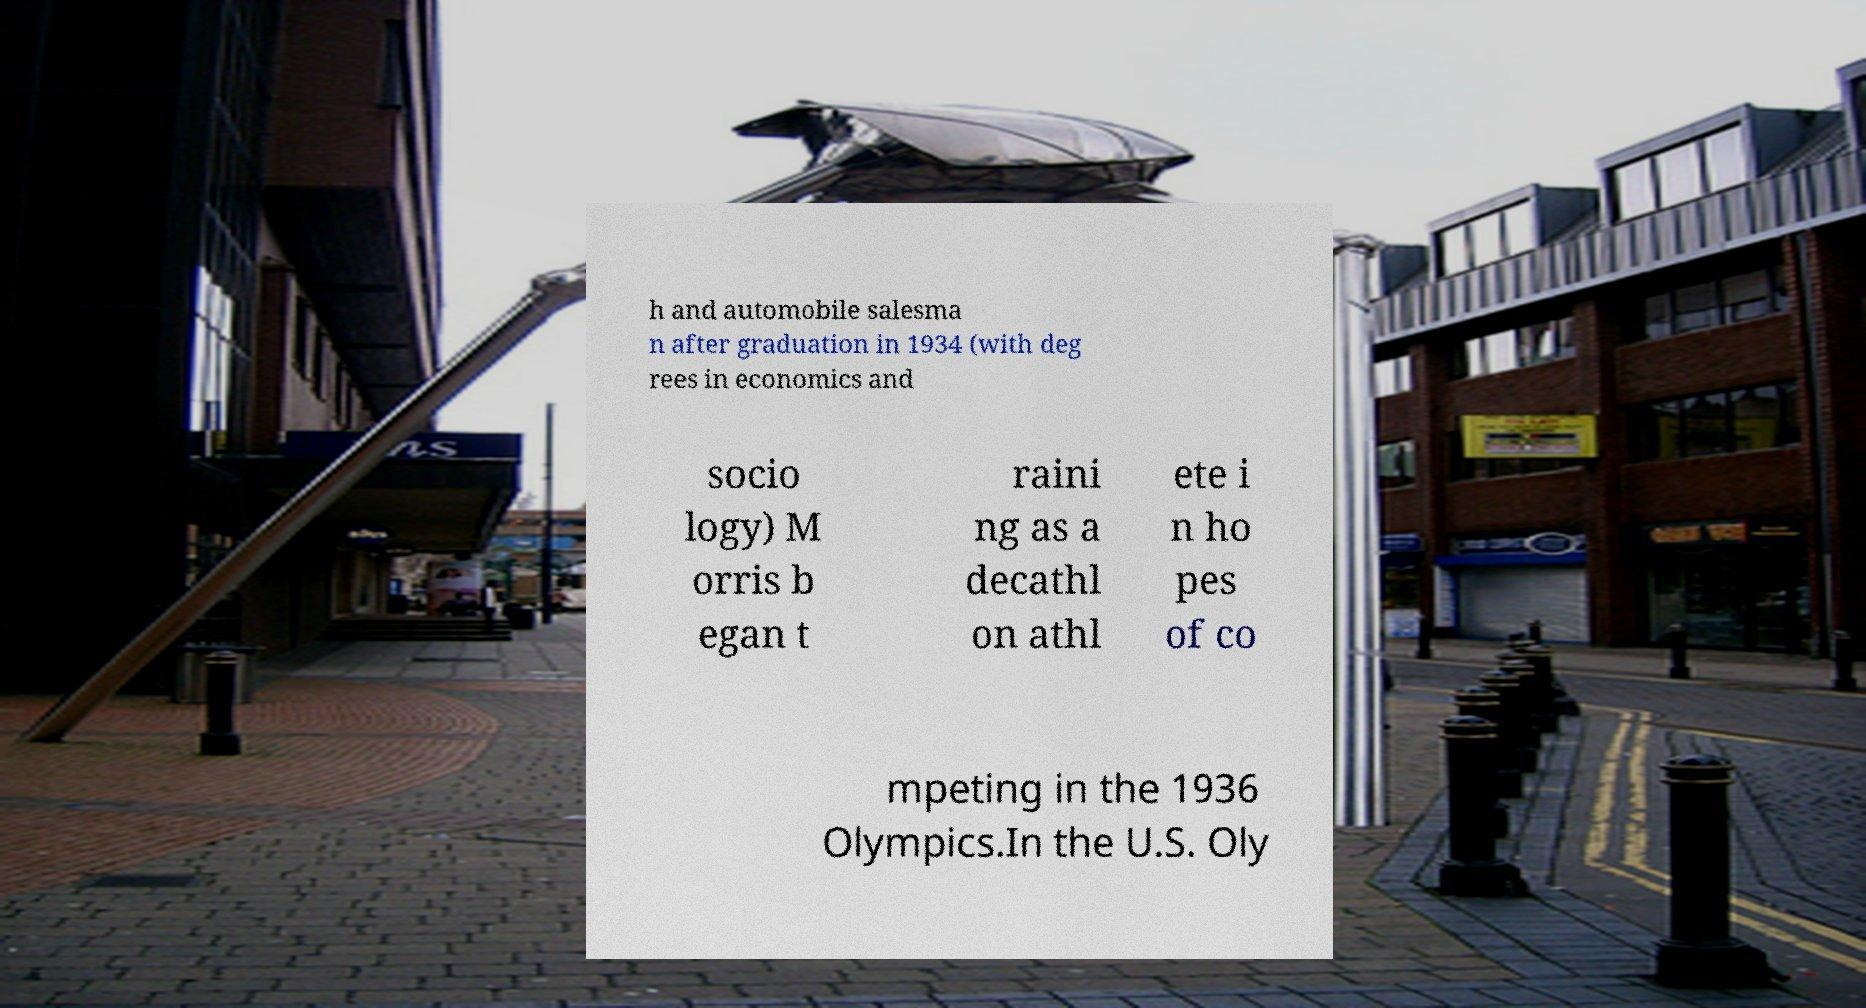Please read and relay the text visible in this image. What does it say? h and automobile salesma n after graduation in 1934 (with deg rees in economics and socio logy) M orris b egan t raini ng as a decathl on athl ete i n ho pes of co mpeting in the 1936 Olympics.In the U.S. Oly 